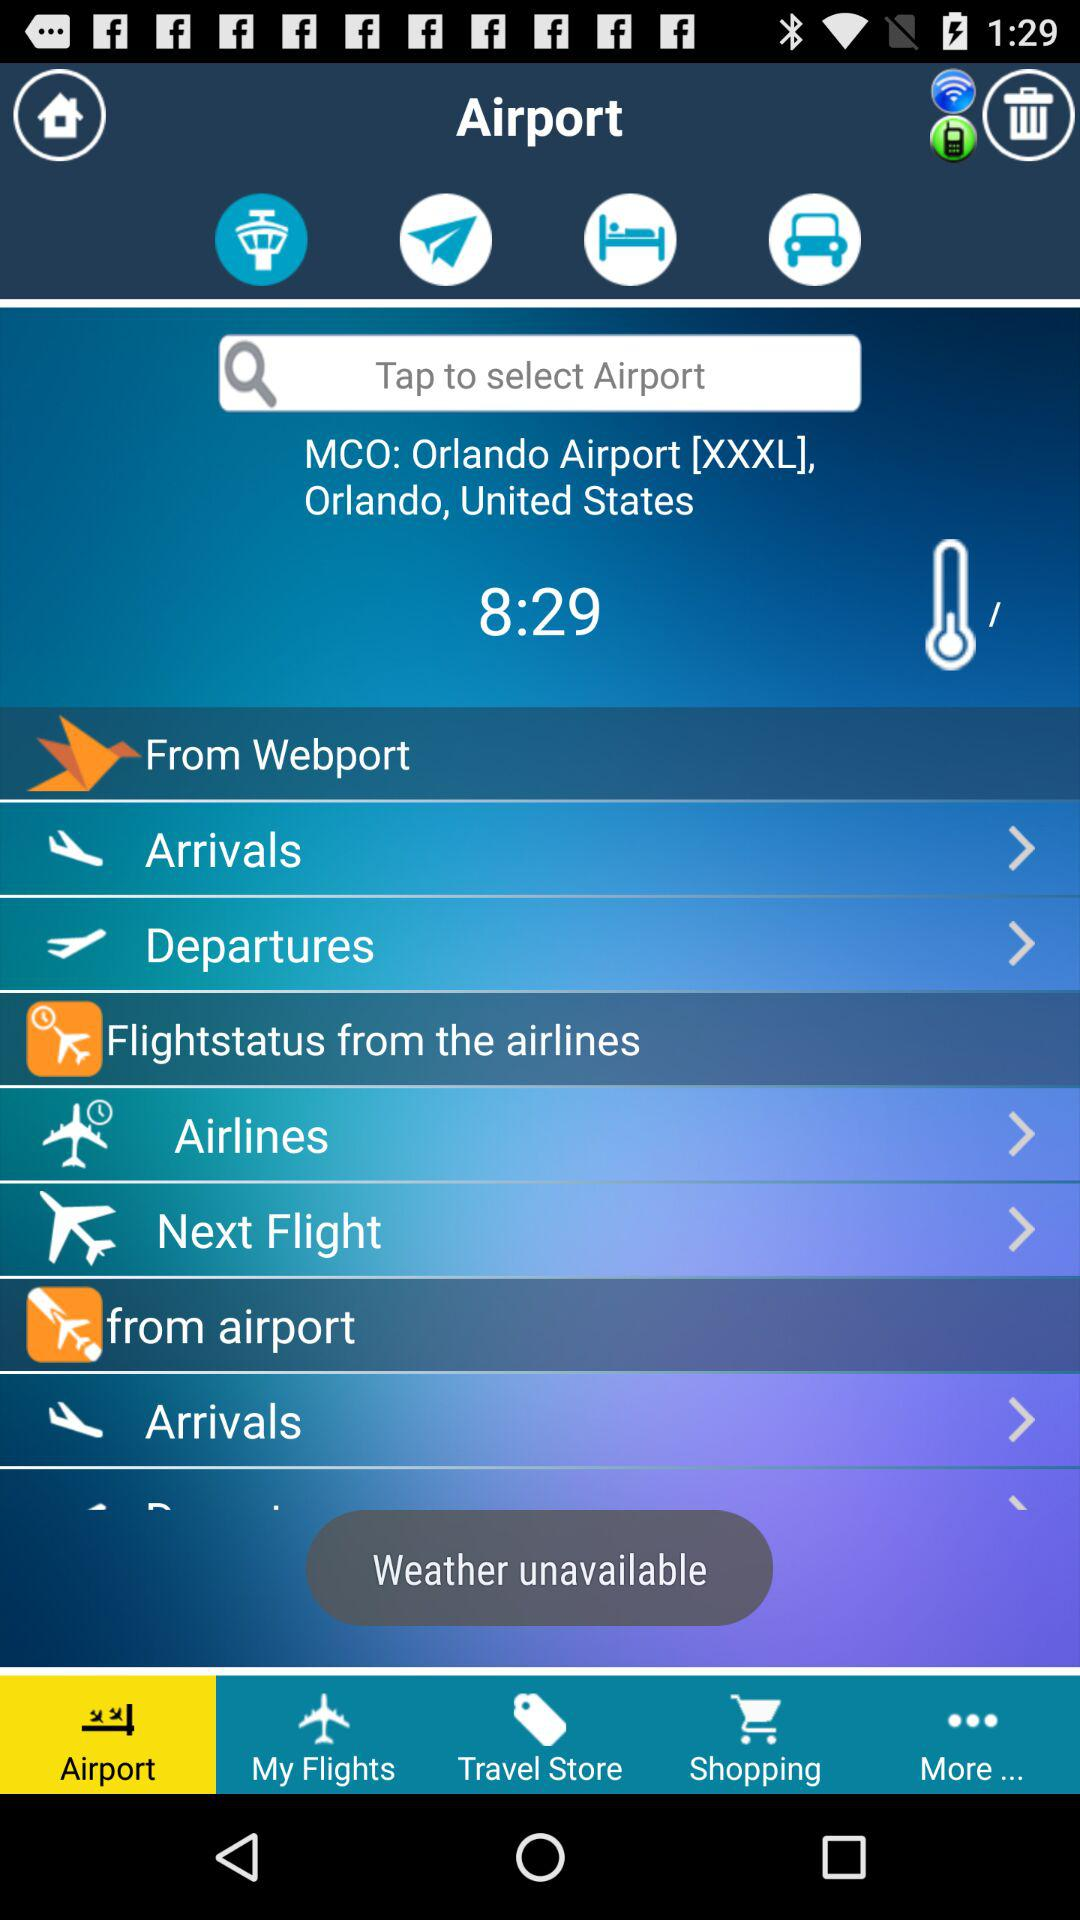What is the location of the airport? The location of the airport is Orlando, United States. 